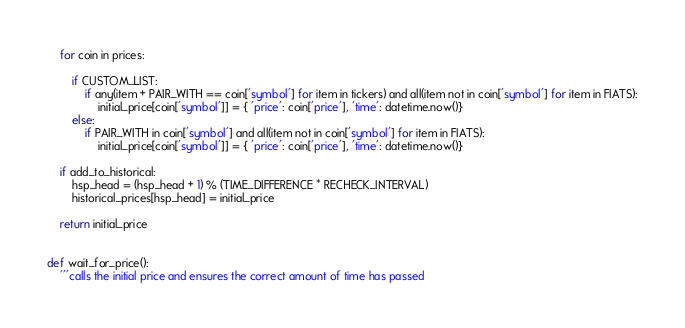<code> <loc_0><loc_0><loc_500><loc_500><_Python_>
    for coin in prices:

        if CUSTOM_LIST:
            if any(item + PAIR_WITH == coin['symbol'] for item in tickers) and all(item not in coin['symbol'] for item in FIATS):
                initial_price[coin['symbol']] = { 'price': coin['price'], 'time': datetime.now()}
        else:
            if PAIR_WITH in coin['symbol'] and all(item not in coin['symbol'] for item in FIATS):
                initial_price[coin['symbol']] = { 'price': coin['price'], 'time': datetime.now()}

    if add_to_historical:
        hsp_head = (hsp_head + 1) % (TIME_DIFFERENCE * RECHECK_INTERVAL)
        historical_prices[hsp_head] = initial_price

    return initial_price


def wait_for_price():
    '''calls the initial price and ensures the correct amount of time has passed</code> 